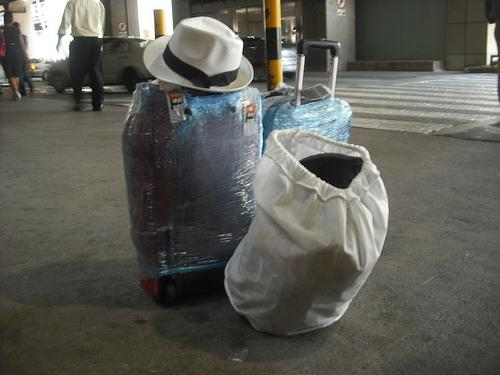Using descriptive language, draw attention to the most visually striking features of the image. A captivating white and black fedora hat rests atop a vibrant blue wrapped suitcase, as a man clad in a crisp white shirt and stark black pants lingers nearby. Explain the main focus of the image, along with any notable visual elements. The image focuses on a man near a blue wrapped suitcase with a white and black fedora hat on it, and other elements like a woman walking and a white crosswalk in the background add context. Mention three primary elements in the image and how they contribute to the overall scene. A white and black fedora hat embellishes a suitcase, a man stands beside multiple bags and suitcases, and a woman walks in the background, creating a bustling, travel-oriented atmosphere. Describe the scene depicted in the image, focusing on the interaction between people and objects. In a busy area, a man in white shirt and black pants stands near a group of suitcases, including a blue suitcase with a white and black fedora hat on it, while a woman in black dress walks away. Summarize the image content in a single sentence, mentioning the main objects and actions. A man and a woman are in a busy location with suitcases, a white bag, and a white and black fedora hat. Write a series of short observations about different objects and people in the image. 5. A white car is driving away in the background. Write a brief description of the image, focusing on any emotions or narratives it may suggest. In a lively setting, a man stands near a collection of suitcases, one adorned with a stylish white and black fedora hat, while a woman in a black dress walks away, evoking a sense of departure or reunion. Imagine you are describing the scene to a friend over the phone, mentioning key details in a casual manner. So there's this guy in a white shirt and black pants by some suitcases, one of them has a white and black fedora hat on it, and there's a woman walking away. Oh, and there's a white car driving off in the background. List three prominent objects in the image along with their colors and relative positions. A white and black fedora hat on top of a blue wrapped suitcase, a white bag by the suitcases, and a man with a white shirt and black pants standing nearby. Identify three relevant items from the image and describe their appearances and purpose. A white and black fedora hat is placed on a suitcase as an accessory, a blue wrapped suitcase stores belongings, and a white crosswalk guides pedestrians through a busy area. 